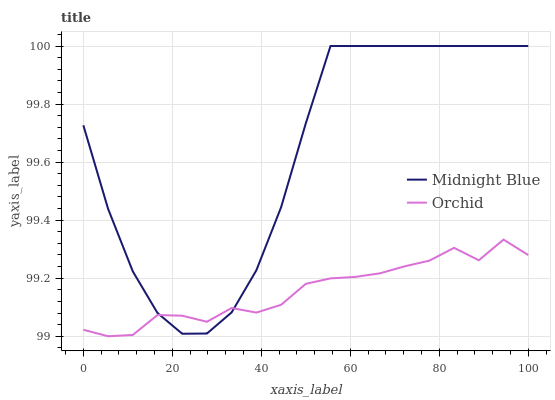Does Orchid have the maximum area under the curve?
Answer yes or no. No. Is Orchid the roughest?
Answer yes or no. No. Does Orchid have the highest value?
Answer yes or no. No. 